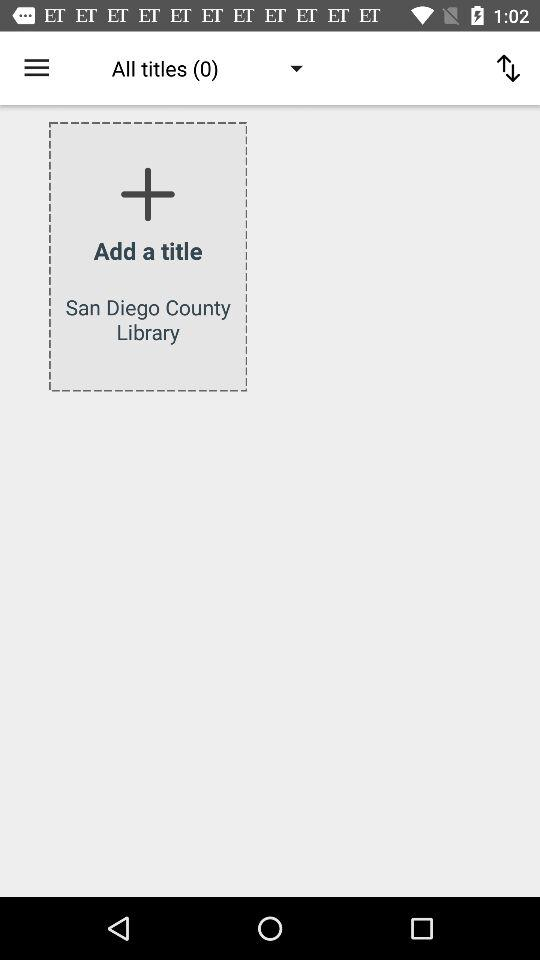What is the name of the library shown on the screen? The name of the library shown on the screen is San Diego County. 